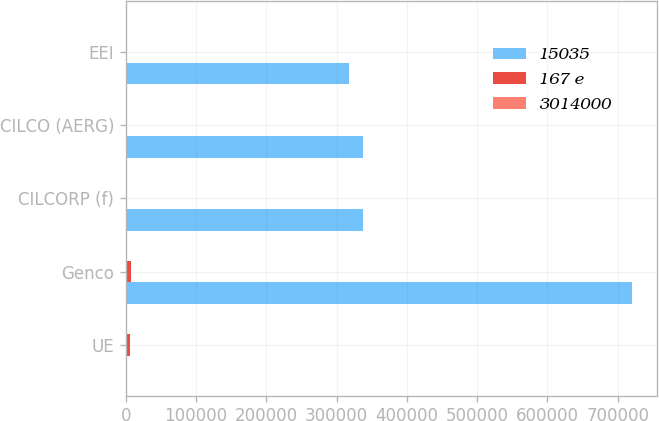Convert chart to OTSL. <chart><loc_0><loc_0><loc_500><loc_500><stacked_bar_chart><ecel><fcel>UE<fcel>Genco<fcel>CILCORP (f)<fcel>CILCO (AERG)<fcel>EEI<nl><fcel>15035<fcel>702.5<fcel>720000<fcel>337000<fcel>337000<fcel>317000<nl><fcel>167 e<fcel>5505<fcel>8125<fcel>209<fcel>209<fcel>1196<nl><fcel>3014000<fcel>48<fcel>49<fcel>35<fcel>1<fcel>9<nl></chart> 